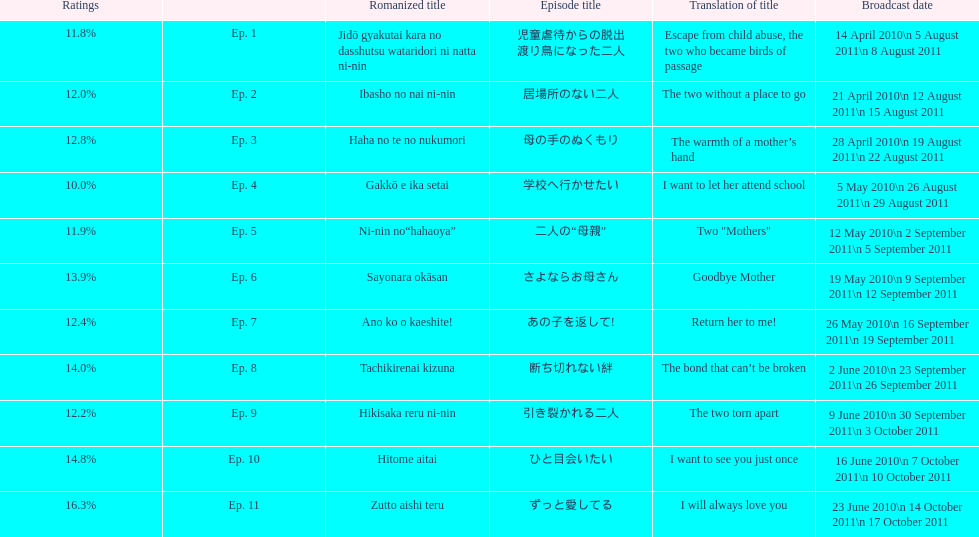What episode number was the only episode to have over 16% of ratings? 11. 